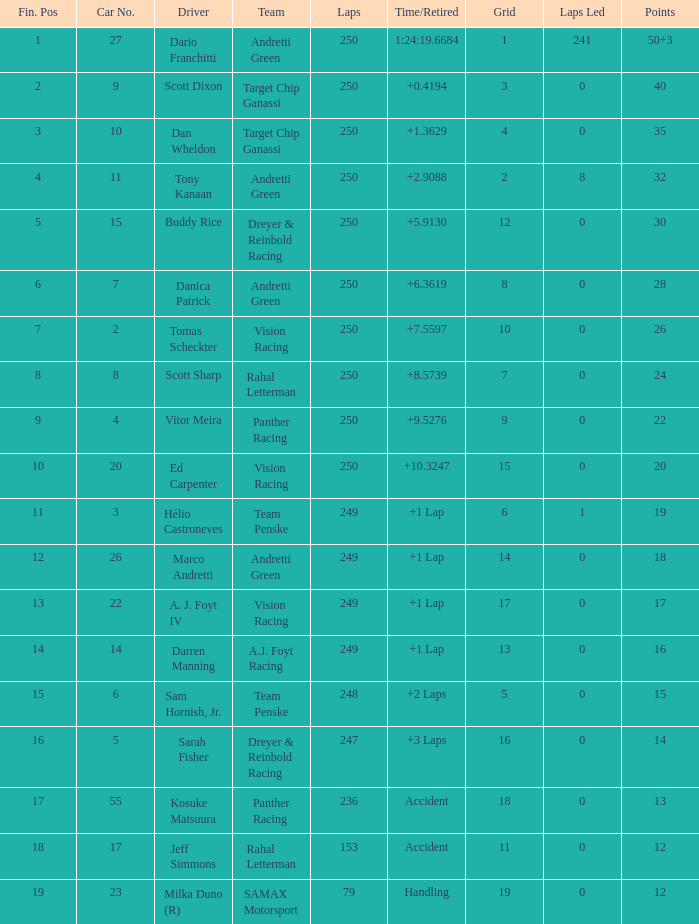State the complete quantity of fin spots for 12 points of mishap. 1.0. 